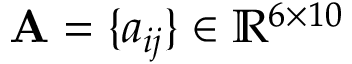Convert formula to latex. <formula><loc_0><loc_0><loc_500><loc_500>A = \{ a _ { i j } \} \in \mathbb { R } ^ { 6 \times 1 0 }</formula> 